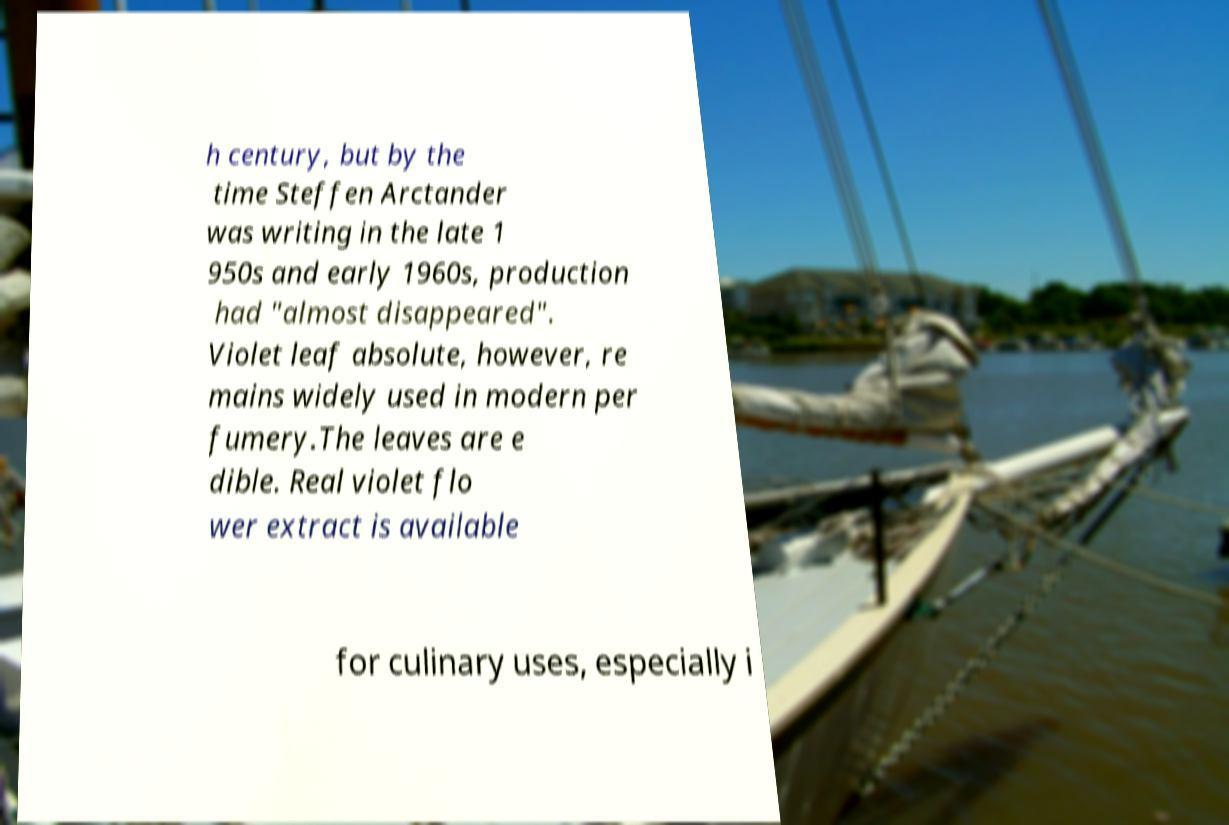What messages or text are displayed in this image? I need them in a readable, typed format. h century, but by the time Steffen Arctander was writing in the late 1 950s and early 1960s, production had "almost disappeared". Violet leaf absolute, however, re mains widely used in modern per fumery.The leaves are e dible. Real violet flo wer extract is available for culinary uses, especially i 